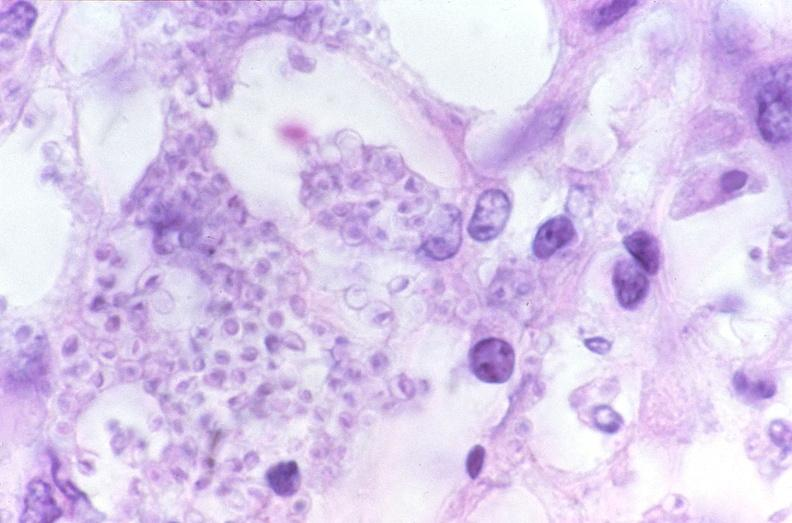what does this image show?
Answer the question using a single word or phrase. Lung 